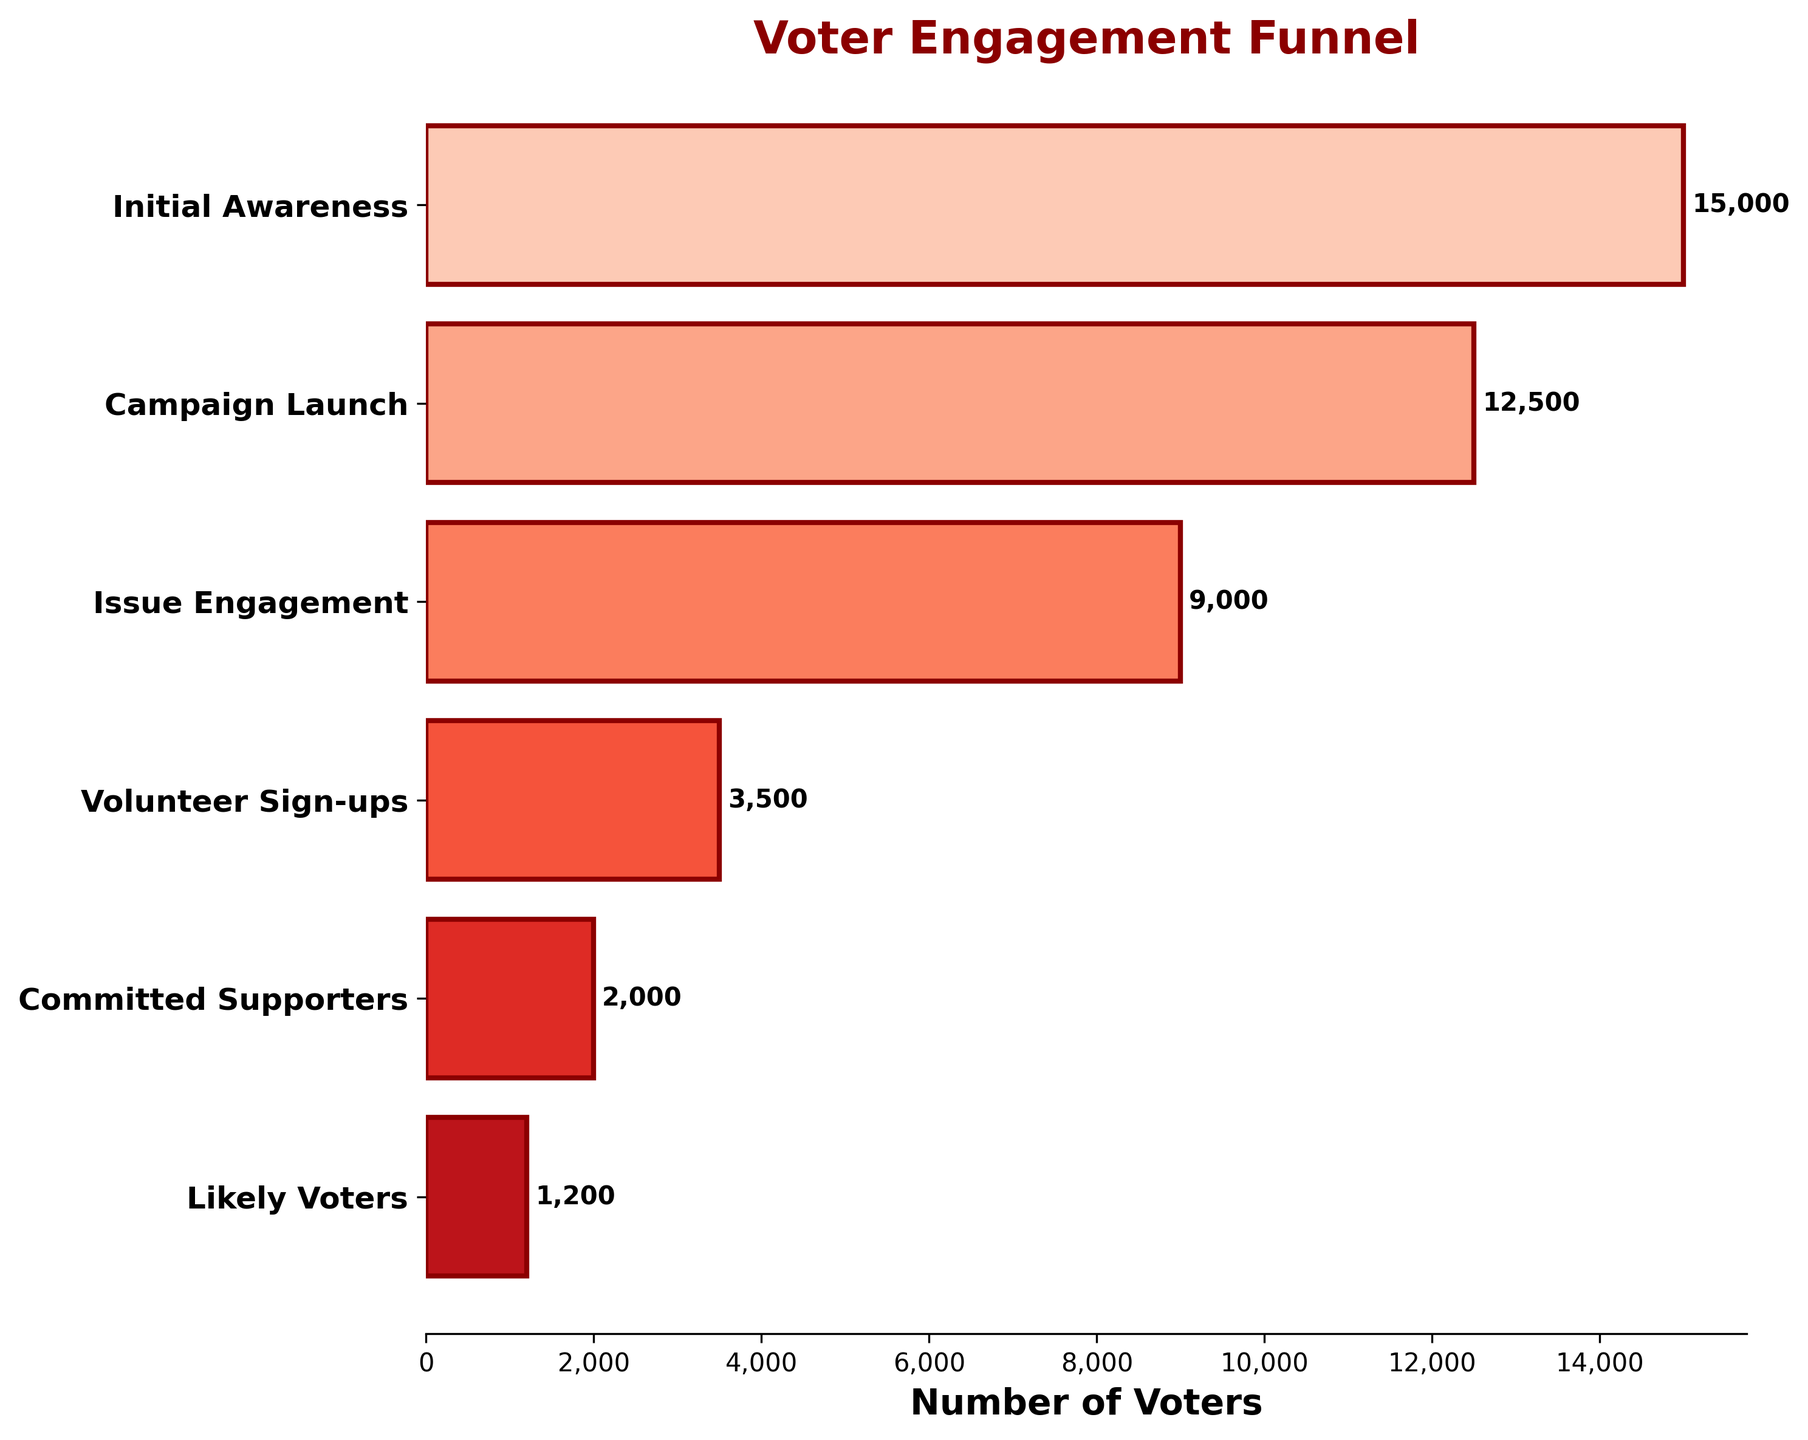What's the title of the funnel chart? The title is at the top of the figure and usually summarizes the content of the chart.
Answer: Voter Engagement Funnel How many stages are represented in the funnel chart? The number of stages is equal to the number of horizontal bars in the chart. We count the distinct labels on the y-axis.
Answer: 6 Which stage has the highest number of voters? The stage with the highest number of voters is represented by the longest horizontal bar. Looking at the bar with the widest span and corresponding y-axis label will give us this information.
Answer: Initial Awareness What is the total number of voters engaged by the end of the "Committed Supporters" stage? Sum the number of voters from all the stages up to and including "Committed Supporters," which are: 15000 (Initial Awareness), 12500 (Campaign Launch), 9000 (Issue Engagement), 3500 (Volunteer Sign-ups), 2000 (Committed Supporters).
Answer: 42,000 How many more voters are there in the "Initial Awareness" stage compared to the "Likely Voters" stage? Subtract the number of voters in the "Likely Voters" stage from those in the "Initial Awareness" stage. So we calculate 15000 - 1200.
Answer: 13,800 What percentage of "Volunteer Sign-ups" converted to "Likely Voters"? First, calculate the conversion number by subtracting "Likely Voters" from "Volunteer Sign-ups" (1200). Then, divide the number of "Likely Voters" by the number of "Volunteer Sign-ups" and multiply by 100 for percentage: (1200 / 3500) * 100.
Answer: 34.3% What stage has the smallest number of voters? The stage with the smallest number of voters is represented by the shortest horizontal bar. Checking the bar with the narrowest width and its corresponding y-axis label will give this information.
Answer: Likely Voters How many stages lose more than 50% of the voters from the previous stage? Subtract the number of voters in each stage from the number of voters in the previous stage, then check if the loss is more than half. For each stage, if the resulting number divided by the previous stage's voters is greater than 0.5, then it qualifies. We find there are two such transitions: from "Campaign Launch" to "Issue Engagement", and from "Volunteer Sign-ups" to "Committed Supporters".
Answer: 2 What's the drop-off rate from "Issue Engagement" to "Volunteer Sign-ups"? First, find the difference in voter counts between "Issue Engagement" and "Volunteer Sign-ups" (9000 - 3500). Then divide by the number of voters in "Issue Engagement" and multiply by 100 to get the percentage: (5500 / 9000) * 100.
Answer: 61.1% By how much did the number of voters decrease from "Campaign Launch" to "Issue Engagement"? Subtract the number of voters in "Issue Engagement" from the number of voters in "Campaign Launch": 12500 - 9000.
Answer: 3500 